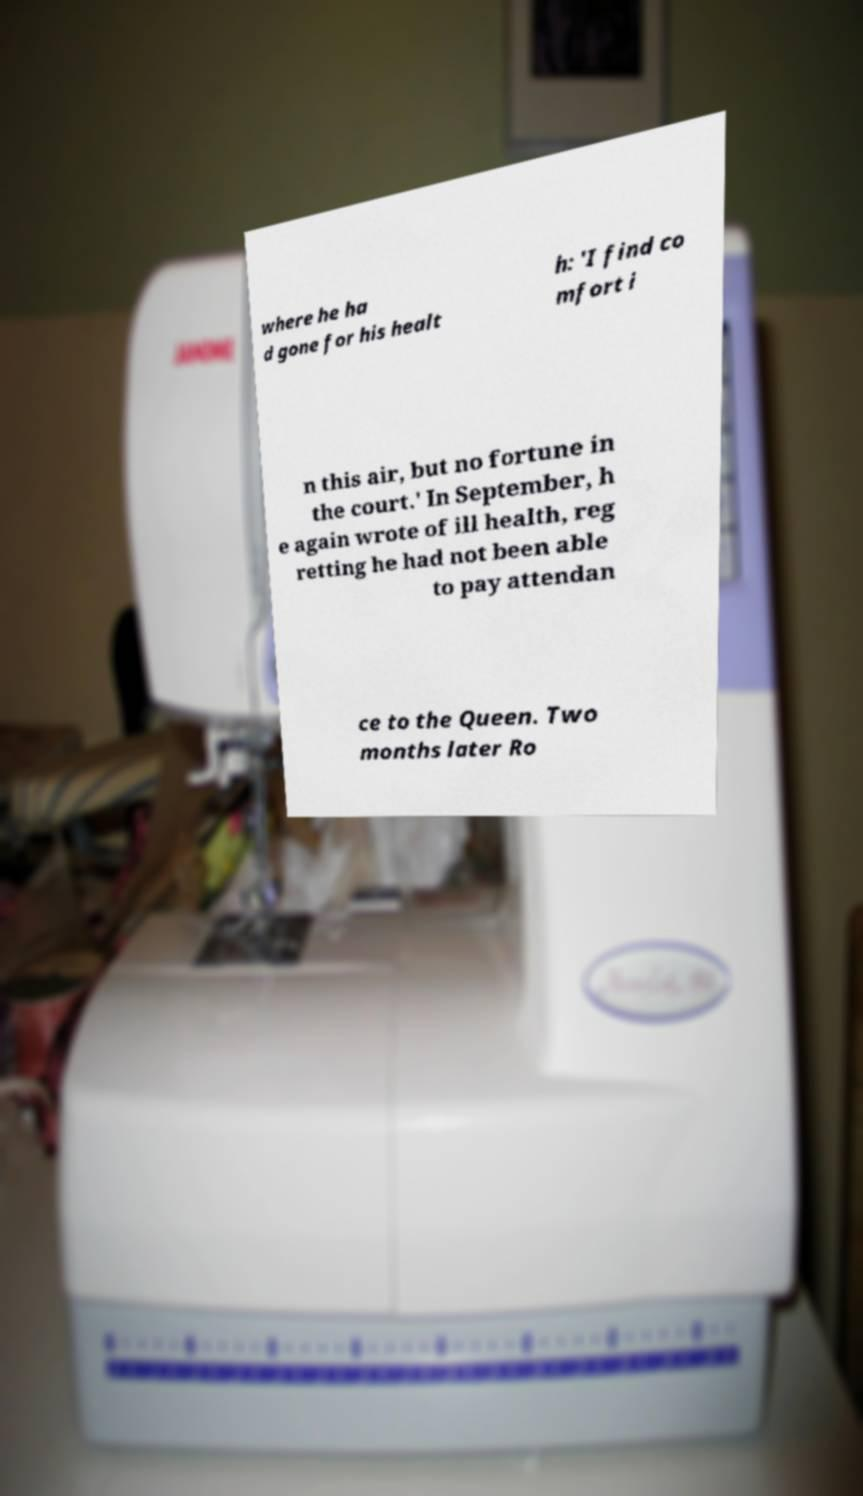What messages or text are displayed in this image? I need them in a readable, typed format. where he ha d gone for his healt h: 'I find co mfort i n this air, but no fortune in the court.' In September, h e again wrote of ill health, reg retting he had not been able to pay attendan ce to the Queen. Two months later Ro 